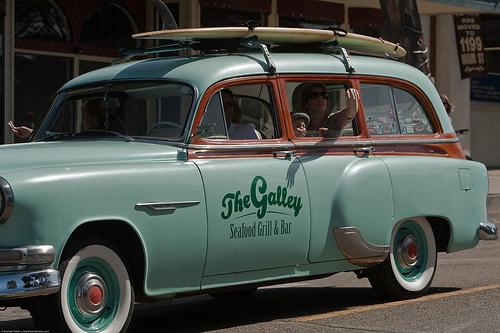Question: where is this picture taken?
Choices:
A. On a beach.
B. A lake.
C. A street.
D. A river.
Answer with the letter. Answer: C Question: what color is the car?
Choices:
A. Blue.
B. Green.
C. Red.
D. White.
Answer with the letter. Answer: B Question: what is the name of the restaurant?
Choices:
A. The Gallery.
B. Walt's.
C. O'Charley's.
D. Applebees.
Answer with the letter. Answer: A Question: what kind of restaurant is advertised?
Choices:
A. A seafood restaurant.
B. A buffet.
C. A pizza place.
D. A steakhouse.
Answer with the letter. Answer: A 